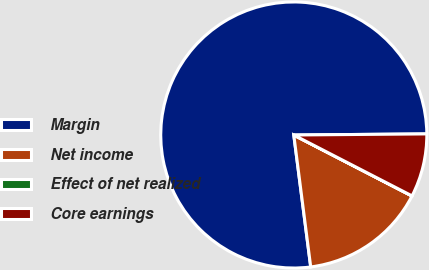Convert chart. <chart><loc_0><loc_0><loc_500><loc_500><pie_chart><fcel>Margin<fcel>Net income<fcel>Effect of net realized<fcel>Core earnings<nl><fcel>76.9%<fcel>15.39%<fcel>0.01%<fcel>7.7%<nl></chart> 